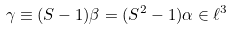<formula> <loc_0><loc_0><loc_500><loc_500>\gamma \equiv ( S - 1 ) \beta = ( S ^ { 2 } - 1 ) \alpha \in \ell ^ { 3 }</formula> 